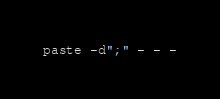<code> <loc_0><loc_0><loc_500><loc_500><_Bash_>paste -d";" - - -</code> 